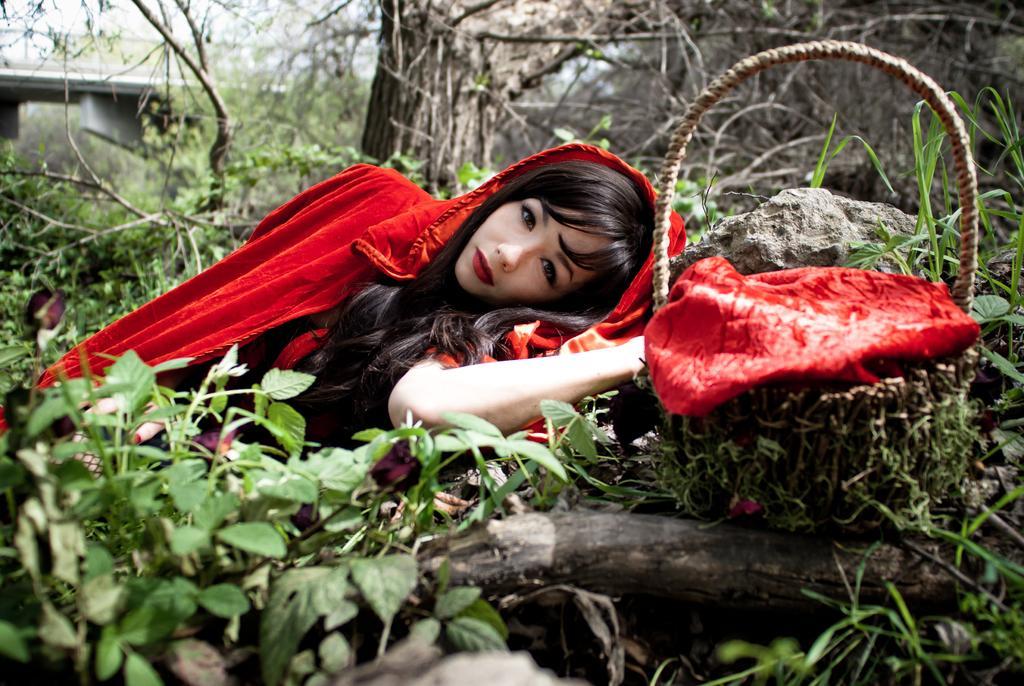Please provide a concise description of this image. In the center of the image a lady is lying on the ground. On the right side of the image a basket is there. In the background of the image we can see trees, plants, stem, grass are present. At the top left corner bridge is there. 